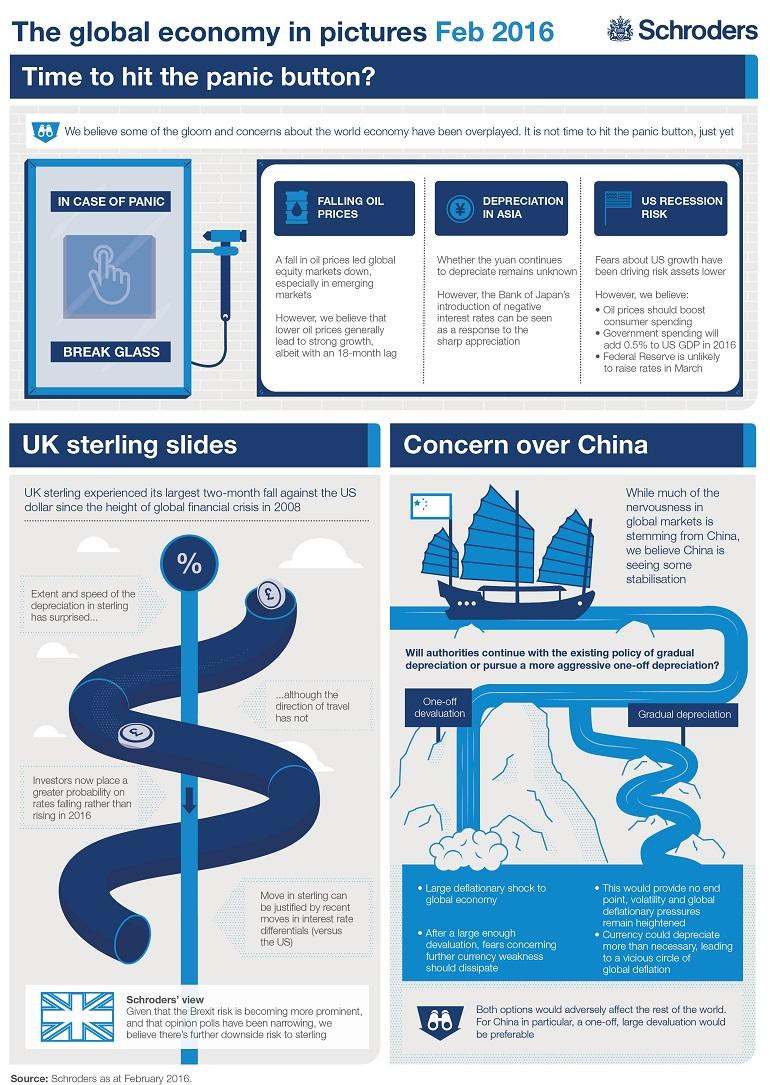List a handful of essential elements in this visual. The authorities are weighing various economic policies to stabilize markets, including a one-off devaluation and a gradual depreciation of the national currency. The current state of the global economy is characterized by multiple economic trends that indicate a crisis. Specifically, there are at least three such trends. 